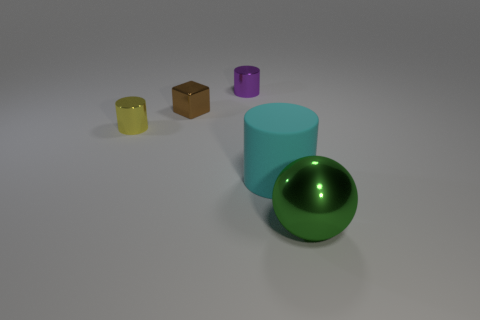Add 5 big cyan things. How many objects exist? 10 Subtract all yellow shiny cylinders. How many cylinders are left? 2 Subtract 1 balls. How many balls are left? 0 Add 3 yellow rubber cylinders. How many yellow rubber cylinders exist? 3 Subtract all cyan cylinders. How many cylinders are left? 2 Subtract 0 blue spheres. How many objects are left? 5 Subtract all cylinders. How many objects are left? 2 Subtract all brown cylinders. Subtract all red cubes. How many cylinders are left? 3 Subtract all red blocks. How many cyan cylinders are left? 1 Subtract all metal spheres. Subtract all tiny cylinders. How many objects are left? 2 